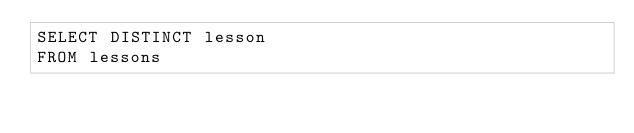Convert code to text. <code><loc_0><loc_0><loc_500><loc_500><_SQL_>SELECT DISTINCT lesson
FROM lessons 


</code> 